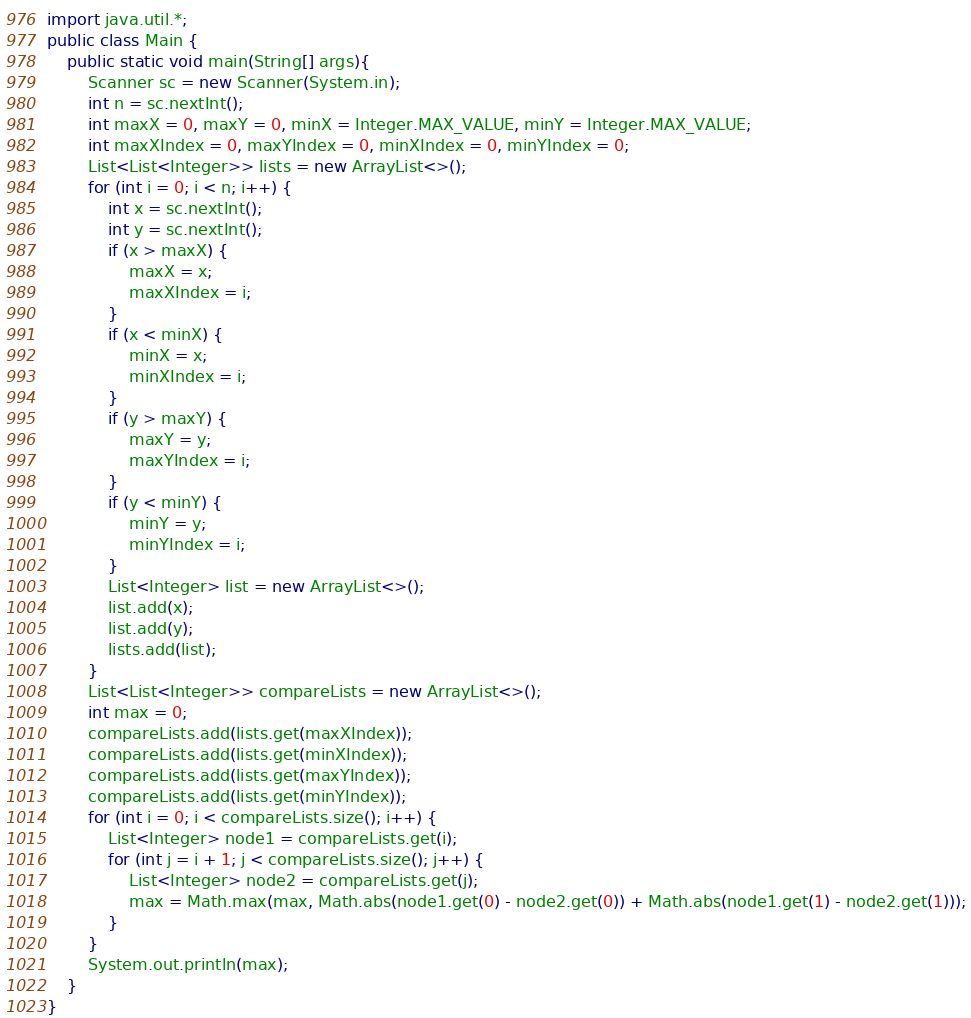Convert code to text. <code><loc_0><loc_0><loc_500><loc_500><_Java_>import java.util.*;
public class Main {
	public static void main(String[] args){
		Scanner sc = new Scanner(System.in);
        int n = sc.nextInt();
        int maxX = 0, maxY = 0, minX = Integer.MAX_VALUE, minY = Integer.MAX_VALUE;
        int maxXIndex = 0, maxYIndex = 0, minXIndex = 0, minYIndex = 0;
        List<List<Integer>> lists = new ArrayList<>();
        for (int i = 0; i < n; i++) {
            int x = sc.nextInt();
            int y = sc.nextInt();
            if (x > maxX) {
                maxX = x;
                maxXIndex = i;
            }
            if (x < minX) {
                minX = x;
                minXIndex = i;
            }
            if (y > maxY) {
                maxY = y;
                maxYIndex = i;
            }
            if (y < minY) {
                minY = y;
                minYIndex = i;
            }
            List<Integer> list = new ArrayList<>();
            list.add(x);
            list.add(y);
            lists.add(list);
        }
        List<List<Integer>> compareLists = new ArrayList<>();
        int max = 0;
        compareLists.add(lists.get(maxXIndex));
        compareLists.add(lists.get(minXIndex));
        compareLists.add(lists.get(maxYIndex));
        compareLists.add(lists.get(minYIndex));
        for (int i = 0; i < compareLists.size(); i++) {
            List<Integer> node1 = compareLists.get(i);
            for (int j = i + 1; j < compareLists.size(); j++) {
                List<Integer> node2 = compareLists.get(j);
                max = Math.max(max, Math.abs(node1.get(0) - node2.get(0)) + Math.abs(node1.get(1) - node2.get(1)));
            }
        }
        System.out.println(max);
	}
}</code> 